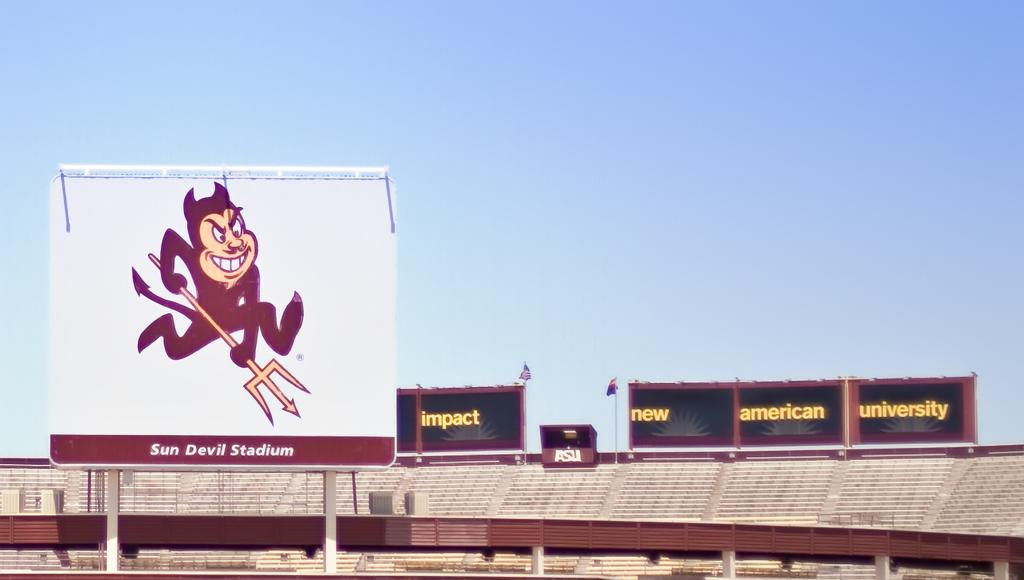<image>
Summarize the visual content of the image. A billboard of an animation of a devil with a pitchfork at the Sun Devil Stadium. 